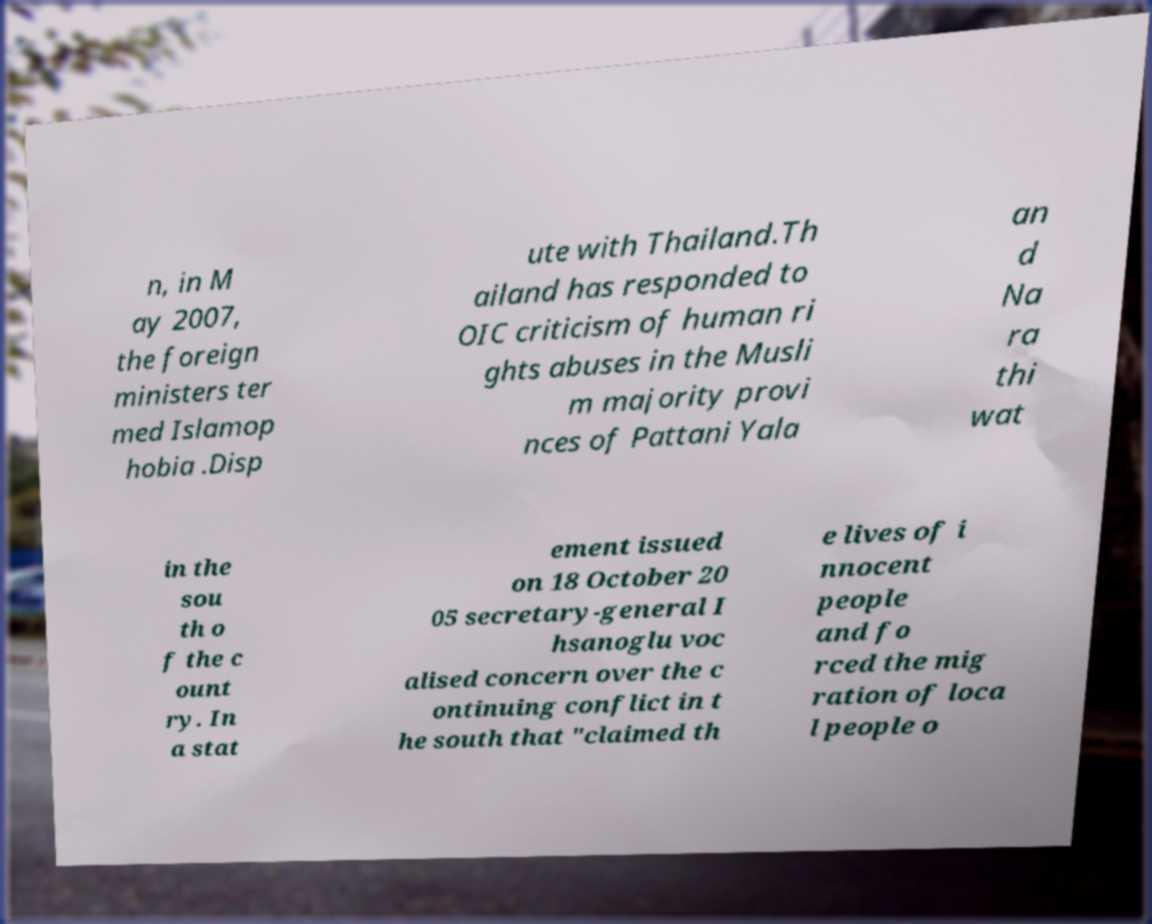What messages or text are displayed in this image? I need them in a readable, typed format. n, in M ay 2007, the foreign ministers ter med Islamop hobia .Disp ute with Thailand.Th ailand has responded to OIC criticism of human ri ghts abuses in the Musli m majority provi nces of Pattani Yala an d Na ra thi wat in the sou th o f the c ount ry. In a stat ement issued on 18 October 20 05 secretary-general I hsanoglu voc alised concern over the c ontinuing conflict in t he south that "claimed th e lives of i nnocent people and fo rced the mig ration of loca l people o 